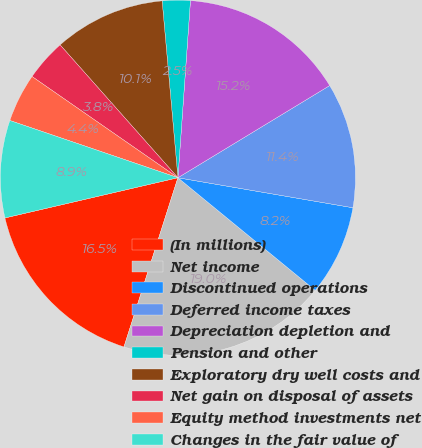Convert chart to OTSL. <chart><loc_0><loc_0><loc_500><loc_500><pie_chart><fcel>(In millions)<fcel>Net income<fcel>Discontinued operations<fcel>Deferred income taxes<fcel>Depreciation depletion and<fcel>Pension and other<fcel>Exploratory dry well costs and<fcel>Net gain on disposal of assets<fcel>Equity method investments net<fcel>Changes in the fair value of<nl><fcel>16.45%<fcel>18.98%<fcel>8.23%<fcel>11.39%<fcel>15.19%<fcel>2.54%<fcel>10.13%<fcel>3.8%<fcel>4.43%<fcel>8.86%<nl></chart> 